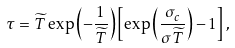Convert formula to latex. <formula><loc_0><loc_0><loc_500><loc_500>\tau = \widetilde { T } \exp \left ( - \frac { 1 } { \widetilde { T } } \right ) \left [ \exp \left ( \frac { \sigma _ { c } } { \sigma \widetilde { T } } \right ) - 1 \right ] ,</formula> 